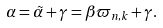<formula> <loc_0><loc_0><loc_500><loc_500>\alpha = \tilde { \alpha } + \gamma = \beta \varpi _ { n , k } + \gamma .</formula> 